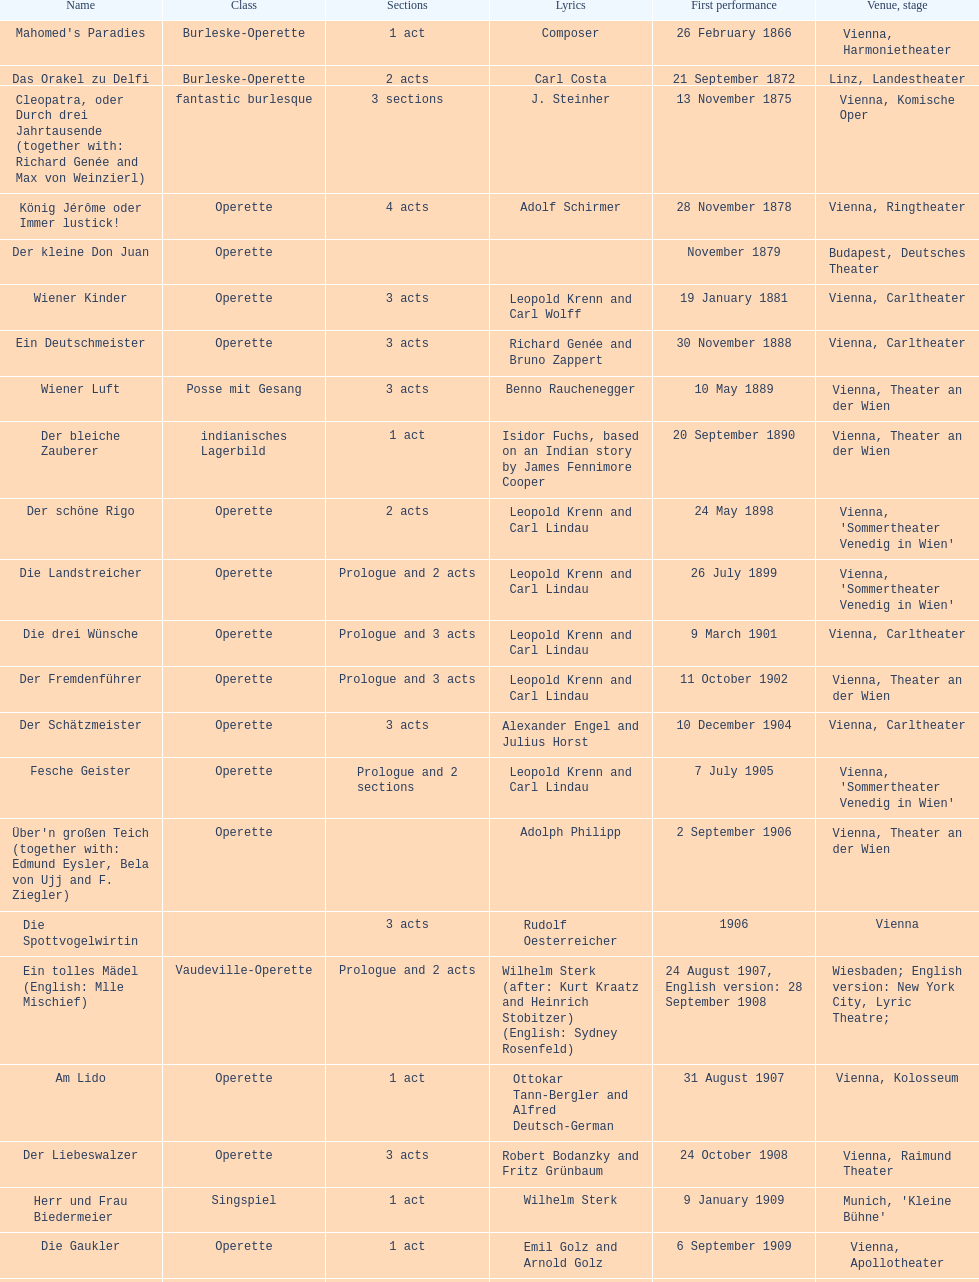What was the year of the last title? 1958. 